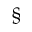Convert formula to latex. <formula><loc_0><loc_0><loc_500><loc_500>\S</formula> 